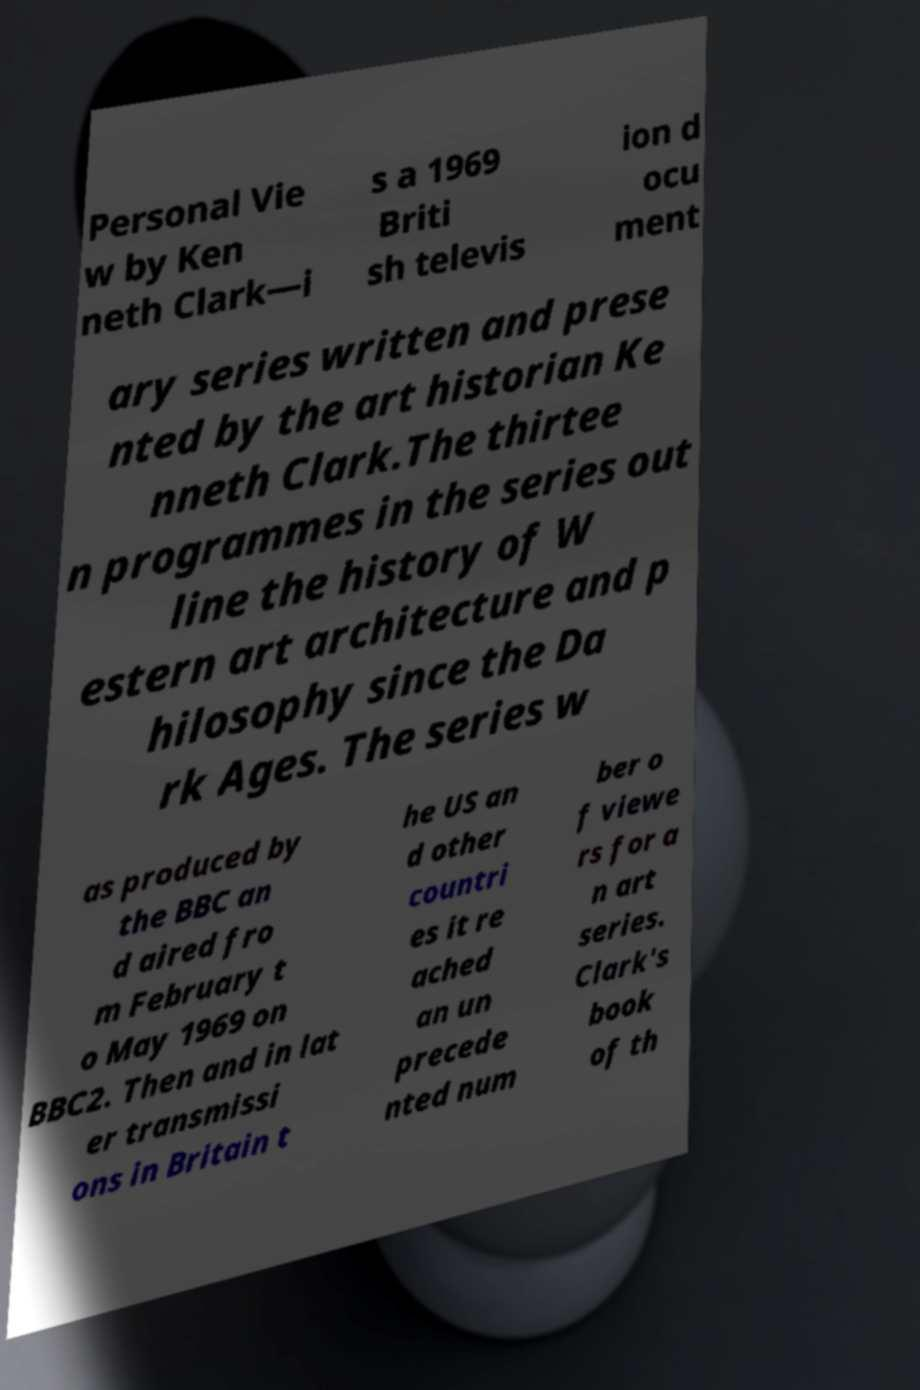Could you assist in decoding the text presented in this image and type it out clearly? Personal Vie w by Ken neth Clark—i s a 1969 Briti sh televis ion d ocu ment ary series written and prese nted by the art historian Ke nneth Clark.The thirtee n programmes in the series out line the history of W estern art architecture and p hilosophy since the Da rk Ages. The series w as produced by the BBC an d aired fro m February t o May 1969 on BBC2. Then and in lat er transmissi ons in Britain t he US an d other countri es it re ached an un precede nted num ber o f viewe rs for a n art series. Clark's book of th 